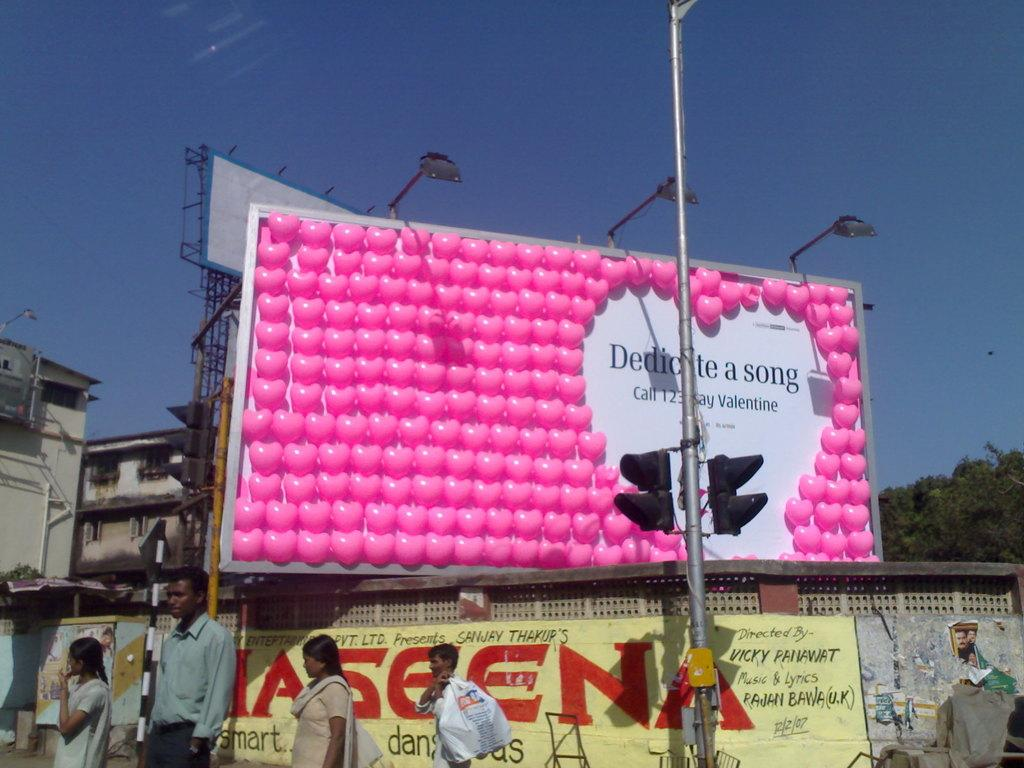Provide a one-sentence caption for the provided image. A billboard is advertising a Valentine's day special using balloons. 